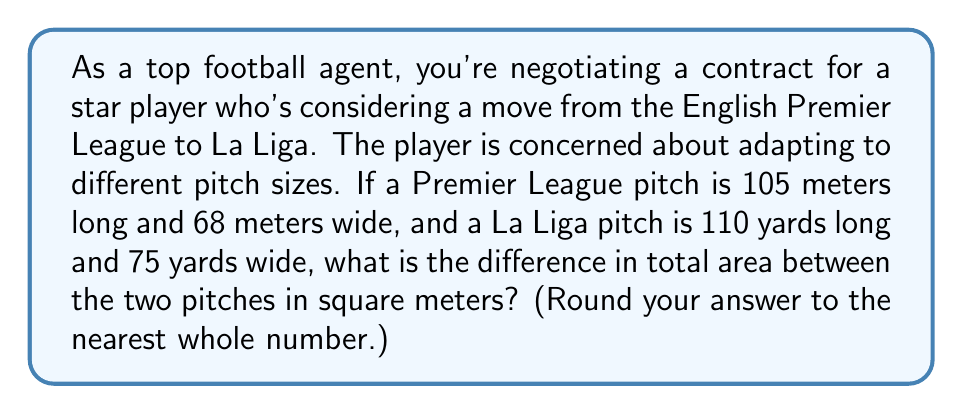What is the answer to this math problem? To solve this problem, we need to follow these steps:

1. Convert the La Liga pitch dimensions from yards to meters:
   $1 \text{ yard} = 0.9144 \text{ meters}$
   
   Length: $110 \text{ yards} \times 0.9144 = 100.584 \text{ meters}$
   Width: $75 \text{ yards} \times 0.9144 = 68.58 \text{ meters}$

2. Calculate the area of the Premier League pitch:
   $$A_{PL} = 105 \text{ m} \times 68 \text{ m} = 7,140 \text{ m}^2$$

3. Calculate the area of the La Liga pitch:
   $$A_{LL} = 100.584 \text{ m} \times 68.58 \text{ m} = 6,898.05 \text{ m}^2$$

4. Find the difference in area:
   $$\text{Difference} = A_{PL} - A_{LL} = 7,140 \text{ m}^2 - 6,898.05 \text{ m}^2 = 241.95 \text{ m}^2$$

5. Round to the nearest whole number:
   $241.95 \text{ m}^2 \approx 242 \text{ m}^2$
Answer: $242 \text{ m}^2$ 